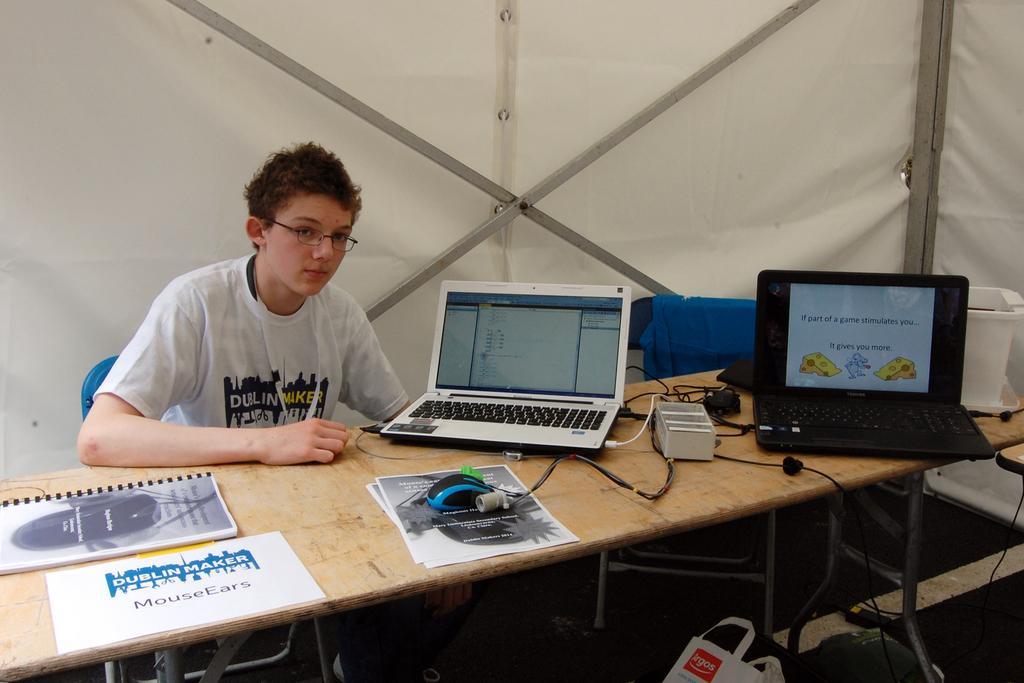How would you summarize this image in a sentence or two? Bottom of the image there is a table on the table there are some papers and book and laptops and mouse and there are some electronic devices. Top left side of the image a man is sitting on a chair. Top right side of the image there is a tent. 